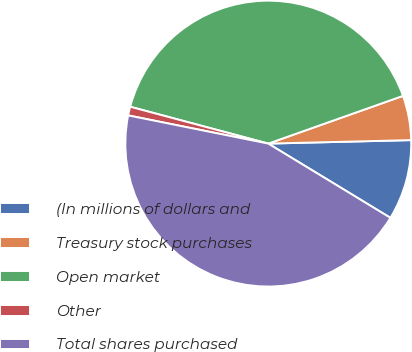Convert chart to OTSL. <chart><loc_0><loc_0><loc_500><loc_500><pie_chart><fcel>(In millions of dollars and<fcel>Treasury stock purchases<fcel>Open market<fcel>Other<fcel>Total shares purchased<nl><fcel>9.08%<fcel>5.03%<fcel>40.43%<fcel>0.99%<fcel>44.47%<nl></chart> 